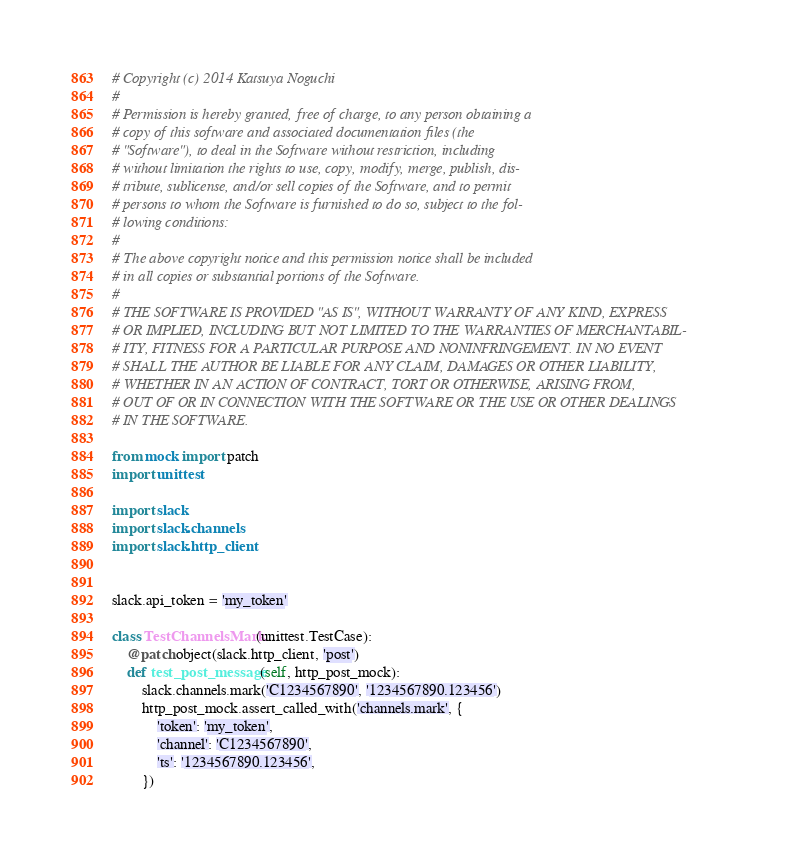<code> <loc_0><loc_0><loc_500><loc_500><_Python_># Copyright (c) 2014 Katsuya Noguchi
#
# Permission is hereby granted, free of charge, to any person obtaining a
# copy of this software and associated documentation files (the
# "Software"), to deal in the Software without restriction, including
# without limitation the rights to use, copy, modify, merge, publish, dis-
# tribute, sublicense, and/or sell copies of the Software, and to permit
# persons to whom the Software is furnished to do so, subject to the fol-
# lowing conditions:
#
# The above copyright notice and this permission notice shall be included
# in all copies or substantial portions of the Software.
#
# THE SOFTWARE IS PROVIDED "AS IS", WITHOUT WARRANTY OF ANY KIND, EXPRESS
# OR IMPLIED, INCLUDING BUT NOT LIMITED TO THE WARRANTIES OF MERCHANTABIL-
# ITY, FITNESS FOR A PARTICULAR PURPOSE AND NONINFRINGEMENT. IN NO EVENT
# SHALL THE AUTHOR BE LIABLE FOR ANY CLAIM, DAMAGES OR OTHER LIABILITY,
# WHETHER IN AN ACTION OF CONTRACT, TORT OR OTHERWISE, ARISING FROM,
# OUT OF OR IN CONNECTION WITH THE SOFTWARE OR THE USE OR OTHER DEALINGS
# IN THE SOFTWARE.

from mock import patch
import unittest

import slack
import slack.channels
import slack.http_client


slack.api_token = 'my_token'

class TestChannelsMark(unittest.TestCase):
    @patch.object(slack.http_client, 'post')
    def test_post_message(self, http_post_mock):
        slack.channels.mark('C1234567890', '1234567890.123456')
        http_post_mock.assert_called_with('channels.mark', {
            'token': 'my_token',
            'channel': 'C1234567890',
            'ts': '1234567890.123456',
        })
</code> 